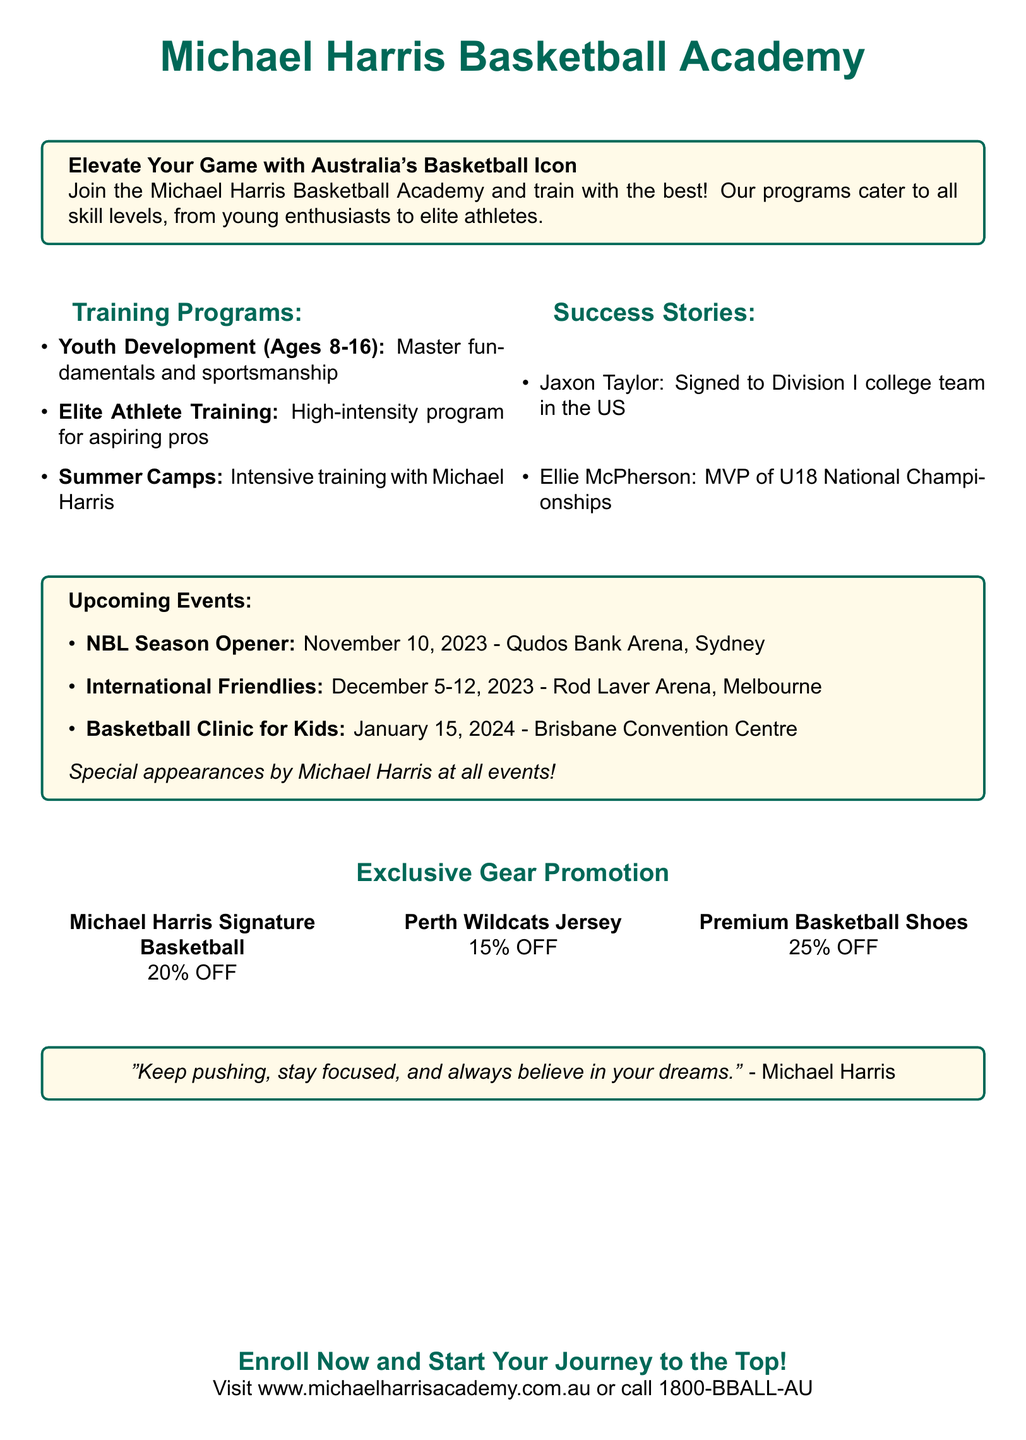What is the age range for the Youth Development program? The Youth Development program is for ages 8 to 16.
Answer: 8-16 Who is the MVP of the U18 National Championships? Ellie McPherson is noted as the MVP of the U18 National Championships.
Answer: Ellie McPherson When is the NBL Season Opener scheduled? The NBL Season Opener is scheduled on November 10, 2023.
Answer: November 10, 2023 What discount is offered on the Premium Basketball Shoes? The discount on the Premium Basketball Shoes is stated to be 25%.
Answer: 25% What programs are available at the Michael Harris Basketball Academy? The programs include Youth Development, Elite Athlete Training, and Summer Camps.
Answer: Youth Development, Elite Athlete Training, Summer Camps What is the main message from Michael Harris in the advertisement? The advertisement quotes Michael Harris as saying, "Keep pushing, stay focused, and always believe in your dreams."
Answer: "Keep pushing, stay focused, and always believe in your dreams." Where can one enroll for the Michael Harris Basketball Academy? Enrollment can be done online at the website provided in the document.
Answer: www.michaelharrisacademy.com.au 